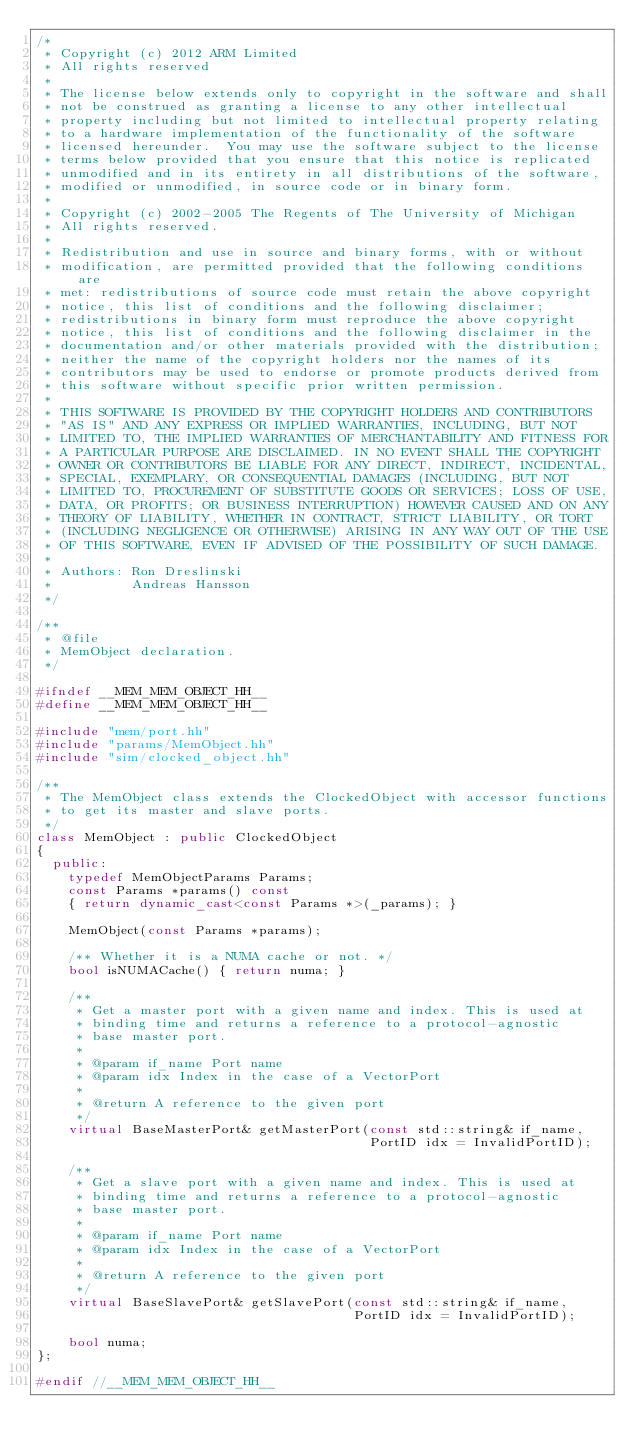<code> <loc_0><loc_0><loc_500><loc_500><_C++_>/*
 * Copyright (c) 2012 ARM Limited
 * All rights reserved
 *
 * The license below extends only to copyright in the software and shall
 * not be construed as granting a license to any other intellectual
 * property including but not limited to intellectual property relating
 * to a hardware implementation of the functionality of the software
 * licensed hereunder.  You may use the software subject to the license
 * terms below provided that you ensure that this notice is replicated
 * unmodified and in its entirety in all distributions of the software,
 * modified or unmodified, in source code or in binary form.
 *
 * Copyright (c) 2002-2005 The Regents of The University of Michigan
 * All rights reserved.
 *
 * Redistribution and use in source and binary forms, with or without
 * modification, are permitted provided that the following conditions are
 * met: redistributions of source code must retain the above copyright
 * notice, this list of conditions and the following disclaimer;
 * redistributions in binary form must reproduce the above copyright
 * notice, this list of conditions and the following disclaimer in the
 * documentation and/or other materials provided with the distribution;
 * neither the name of the copyright holders nor the names of its
 * contributors may be used to endorse or promote products derived from
 * this software without specific prior written permission.
 *
 * THIS SOFTWARE IS PROVIDED BY THE COPYRIGHT HOLDERS AND CONTRIBUTORS
 * "AS IS" AND ANY EXPRESS OR IMPLIED WARRANTIES, INCLUDING, BUT NOT
 * LIMITED TO, THE IMPLIED WARRANTIES OF MERCHANTABILITY AND FITNESS FOR
 * A PARTICULAR PURPOSE ARE DISCLAIMED. IN NO EVENT SHALL THE COPYRIGHT
 * OWNER OR CONTRIBUTORS BE LIABLE FOR ANY DIRECT, INDIRECT, INCIDENTAL,
 * SPECIAL, EXEMPLARY, OR CONSEQUENTIAL DAMAGES (INCLUDING, BUT NOT
 * LIMITED TO, PROCUREMENT OF SUBSTITUTE GOODS OR SERVICES; LOSS OF USE,
 * DATA, OR PROFITS; OR BUSINESS INTERRUPTION) HOWEVER CAUSED AND ON ANY
 * THEORY OF LIABILITY, WHETHER IN CONTRACT, STRICT LIABILITY, OR TORT
 * (INCLUDING NEGLIGENCE OR OTHERWISE) ARISING IN ANY WAY OUT OF THE USE
 * OF THIS SOFTWARE, EVEN IF ADVISED OF THE POSSIBILITY OF SUCH DAMAGE.
 *
 * Authors: Ron Dreslinski
 *          Andreas Hansson
 */

/**
 * @file
 * MemObject declaration.
 */

#ifndef __MEM_MEM_OBJECT_HH__
#define __MEM_MEM_OBJECT_HH__

#include "mem/port.hh"
#include "params/MemObject.hh"
#include "sim/clocked_object.hh"

/**
 * The MemObject class extends the ClockedObject with accessor functions
 * to get its master and slave ports.
 */
class MemObject : public ClockedObject
{
  public:
    typedef MemObjectParams Params;
    const Params *params() const
    { return dynamic_cast<const Params *>(_params); }

    MemObject(const Params *params);

    /** Whether it is a NUMA cache or not. */
    bool isNUMACache() { return numa; }

    /**
     * Get a master port with a given name and index. This is used at
     * binding time and returns a reference to a protocol-agnostic
     * base master port.
     *
     * @param if_name Port name
     * @param idx Index in the case of a VectorPort
     *
     * @return A reference to the given port
     */
    virtual BaseMasterPort& getMasterPort(const std::string& if_name,
                                          PortID idx = InvalidPortID);

    /**
     * Get a slave port with a given name and index. This is used at
     * binding time and returns a reference to a protocol-agnostic
     * base master port.
     *
     * @param if_name Port name
     * @param idx Index in the case of a VectorPort
     *
     * @return A reference to the given port
     */
    virtual BaseSlavePort& getSlavePort(const std::string& if_name,
                                        PortID idx = InvalidPortID);

    bool numa;
};

#endif //__MEM_MEM_OBJECT_HH__
</code> 